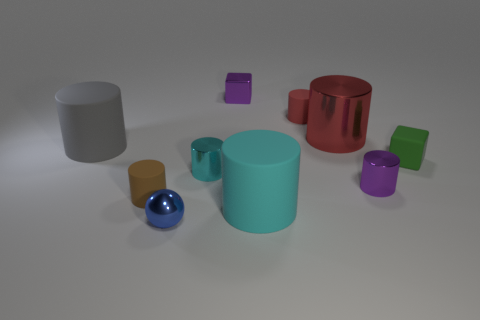What colors are the rubber cylinders in the image? The rubber cylinders come in various colors. There are gray, red, brown, and purple cylinders each presented in a distinct shade. 